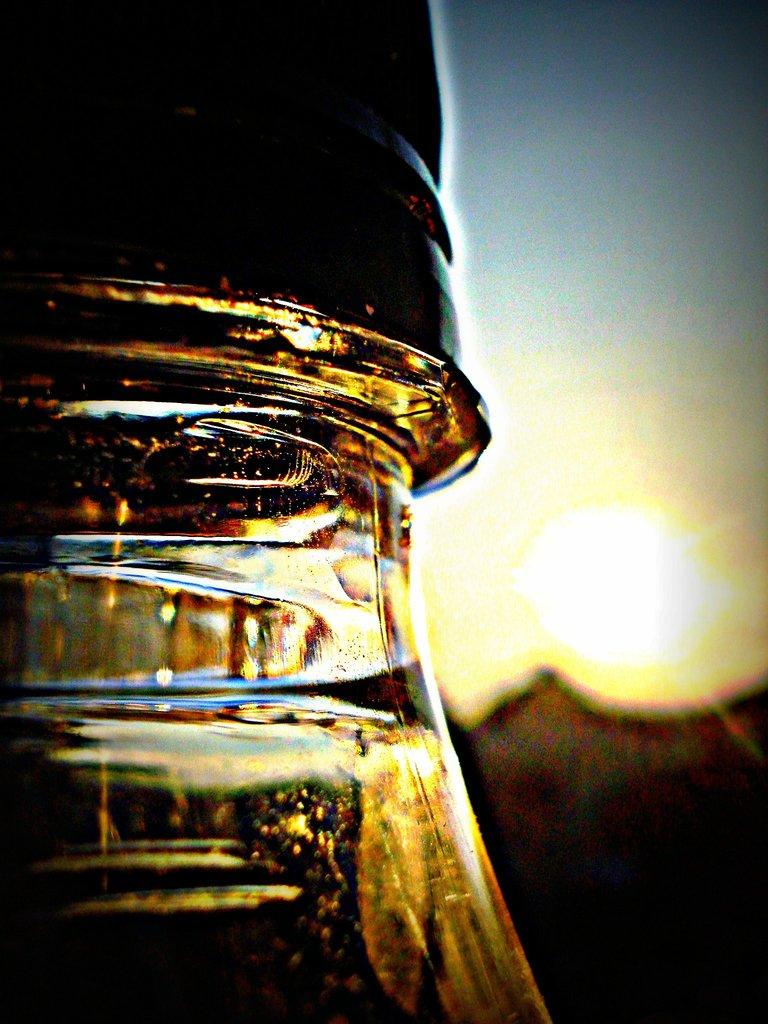What object is located in the front of the image? There is a glass bottle in the front of the image. What can be seen in the background of the image? Sky is visible in the background of the image. Is there a celestial body visible in the sky? Yes, the sun is observable in the sky. Can you tell me how many birds are swimming in the glass bottle in the image? There are no birds or swimming activity present in the image. 